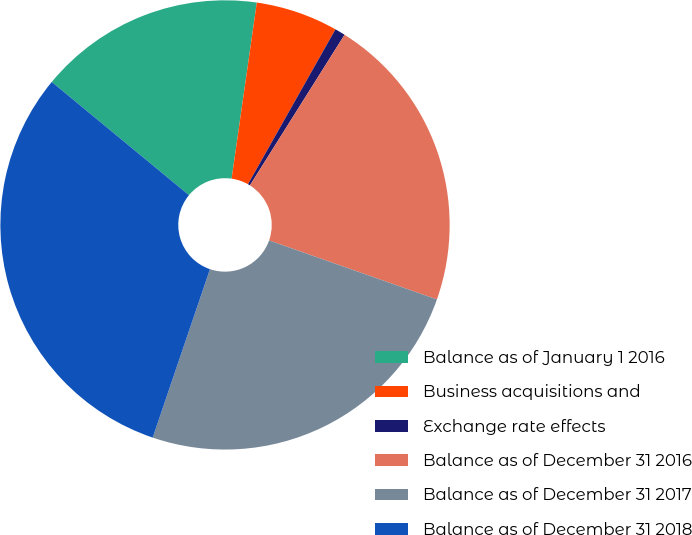Convert chart. <chart><loc_0><loc_0><loc_500><loc_500><pie_chart><fcel>Balance as of January 1 2016<fcel>Business acquisitions and<fcel>Exchange rate effects<fcel>Balance as of December 31 2016<fcel>Balance as of December 31 2017<fcel>Balance as of December 31 2018<nl><fcel>16.28%<fcel>5.92%<fcel>0.75%<fcel>21.45%<fcel>24.83%<fcel>30.76%<nl></chart> 